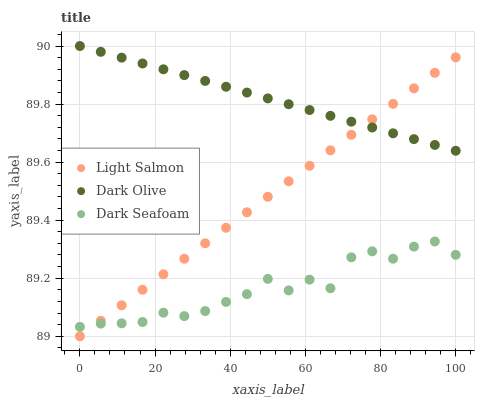Does Dark Seafoam have the minimum area under the curve?
Answer yes or no. Yes. Does Dark Olive have the maximum area under the curve?
Answer yes or no. Yes. Does Dark Olive have the minimum area under the curve?
Answer yes or no. No. Does Dark Seafoam have the maximum area under the curve?
Answer yes or no. No. Is Dark Olive the smoothest?
Answer yes or no. Yes. Is Dark Seafoam the roughest?
Answer yes or no. Yes. Is Dark Seafoam the smoothest?
Answer yes or no. No. Is Dark Olive the roughest?
Answer yes or no. No. Does Light Salmon have the lowest value?
Answer yes or no. Yes. Does Dark Seafoam have the lowest value?
Answer yes or no. No. Does Dark Olive have the highest value?
Answer yes or no. Yes. Does Dark Seafoam have the highest value?
Answer yes or no. No. Is Dark Seafoam less than Dark Olive?
Answer yes or no. Yes. Is Dark Olive greater than Dark Seafoam?
Answer yes or no. Yes. Does Dark Seafoam intersect Light Salmon?
Answer yes or no. Yes. Is Dark Seafoam less than Light Salmon?
Answer yes or no. No. Is Dark Seafoam greater than Light Salmon?
Answer yes or no. No. Does Dark Seafoam intersect Dark Olive?
Answer yes or no. No. 